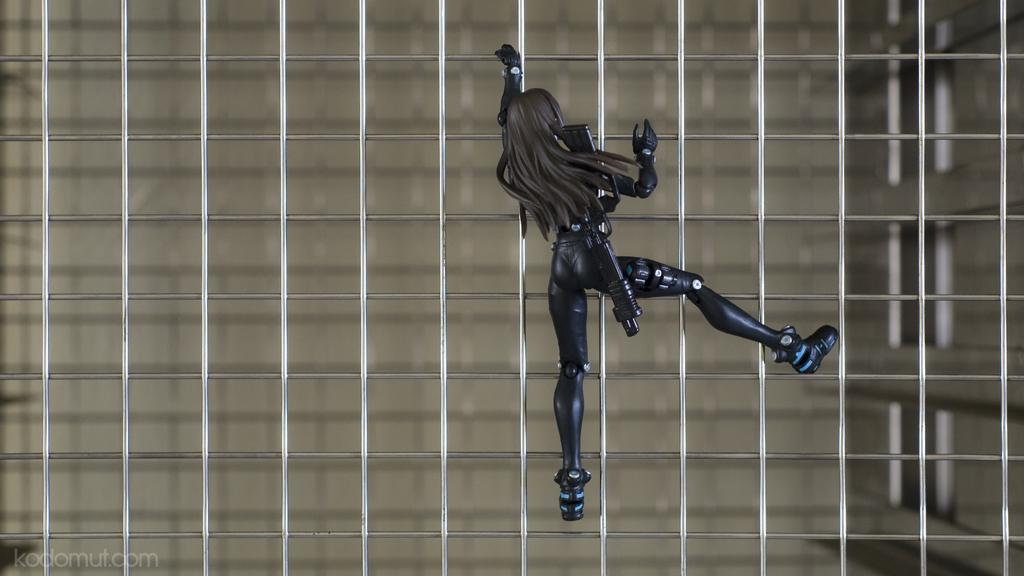What is the main subject of the image? The main subject of the image is a toy of a woman. Where is the toy located in the image? The toy is at the center of the image. Is the toy connected to any other object in the image? Yes, the toy is attached to a mesh. What type of trousers is the woman wearing in the image? The image features a toy of a woman, not an actual person, so it is not possible to determine what type of trousers she might be wearing. 